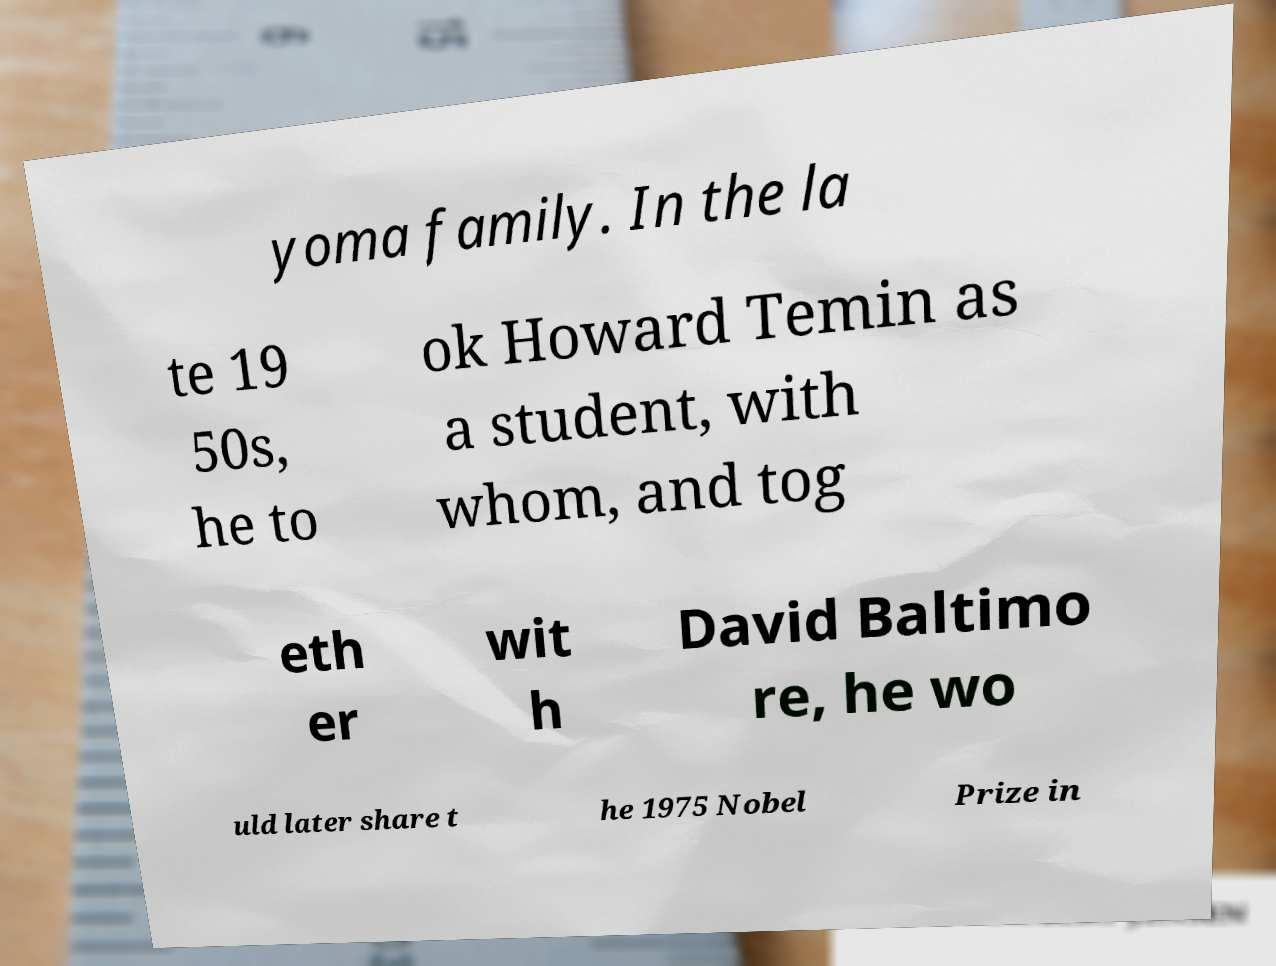For documentation purposes, I need the text within this image transcribed. Could you provide that? yoma family. In the la te 19 50s, he to ok Howard Temin as a student, with whom, and tog eth er wit h David Baltimo re, he wo uld later share t he 1975 Nobel Prize in 